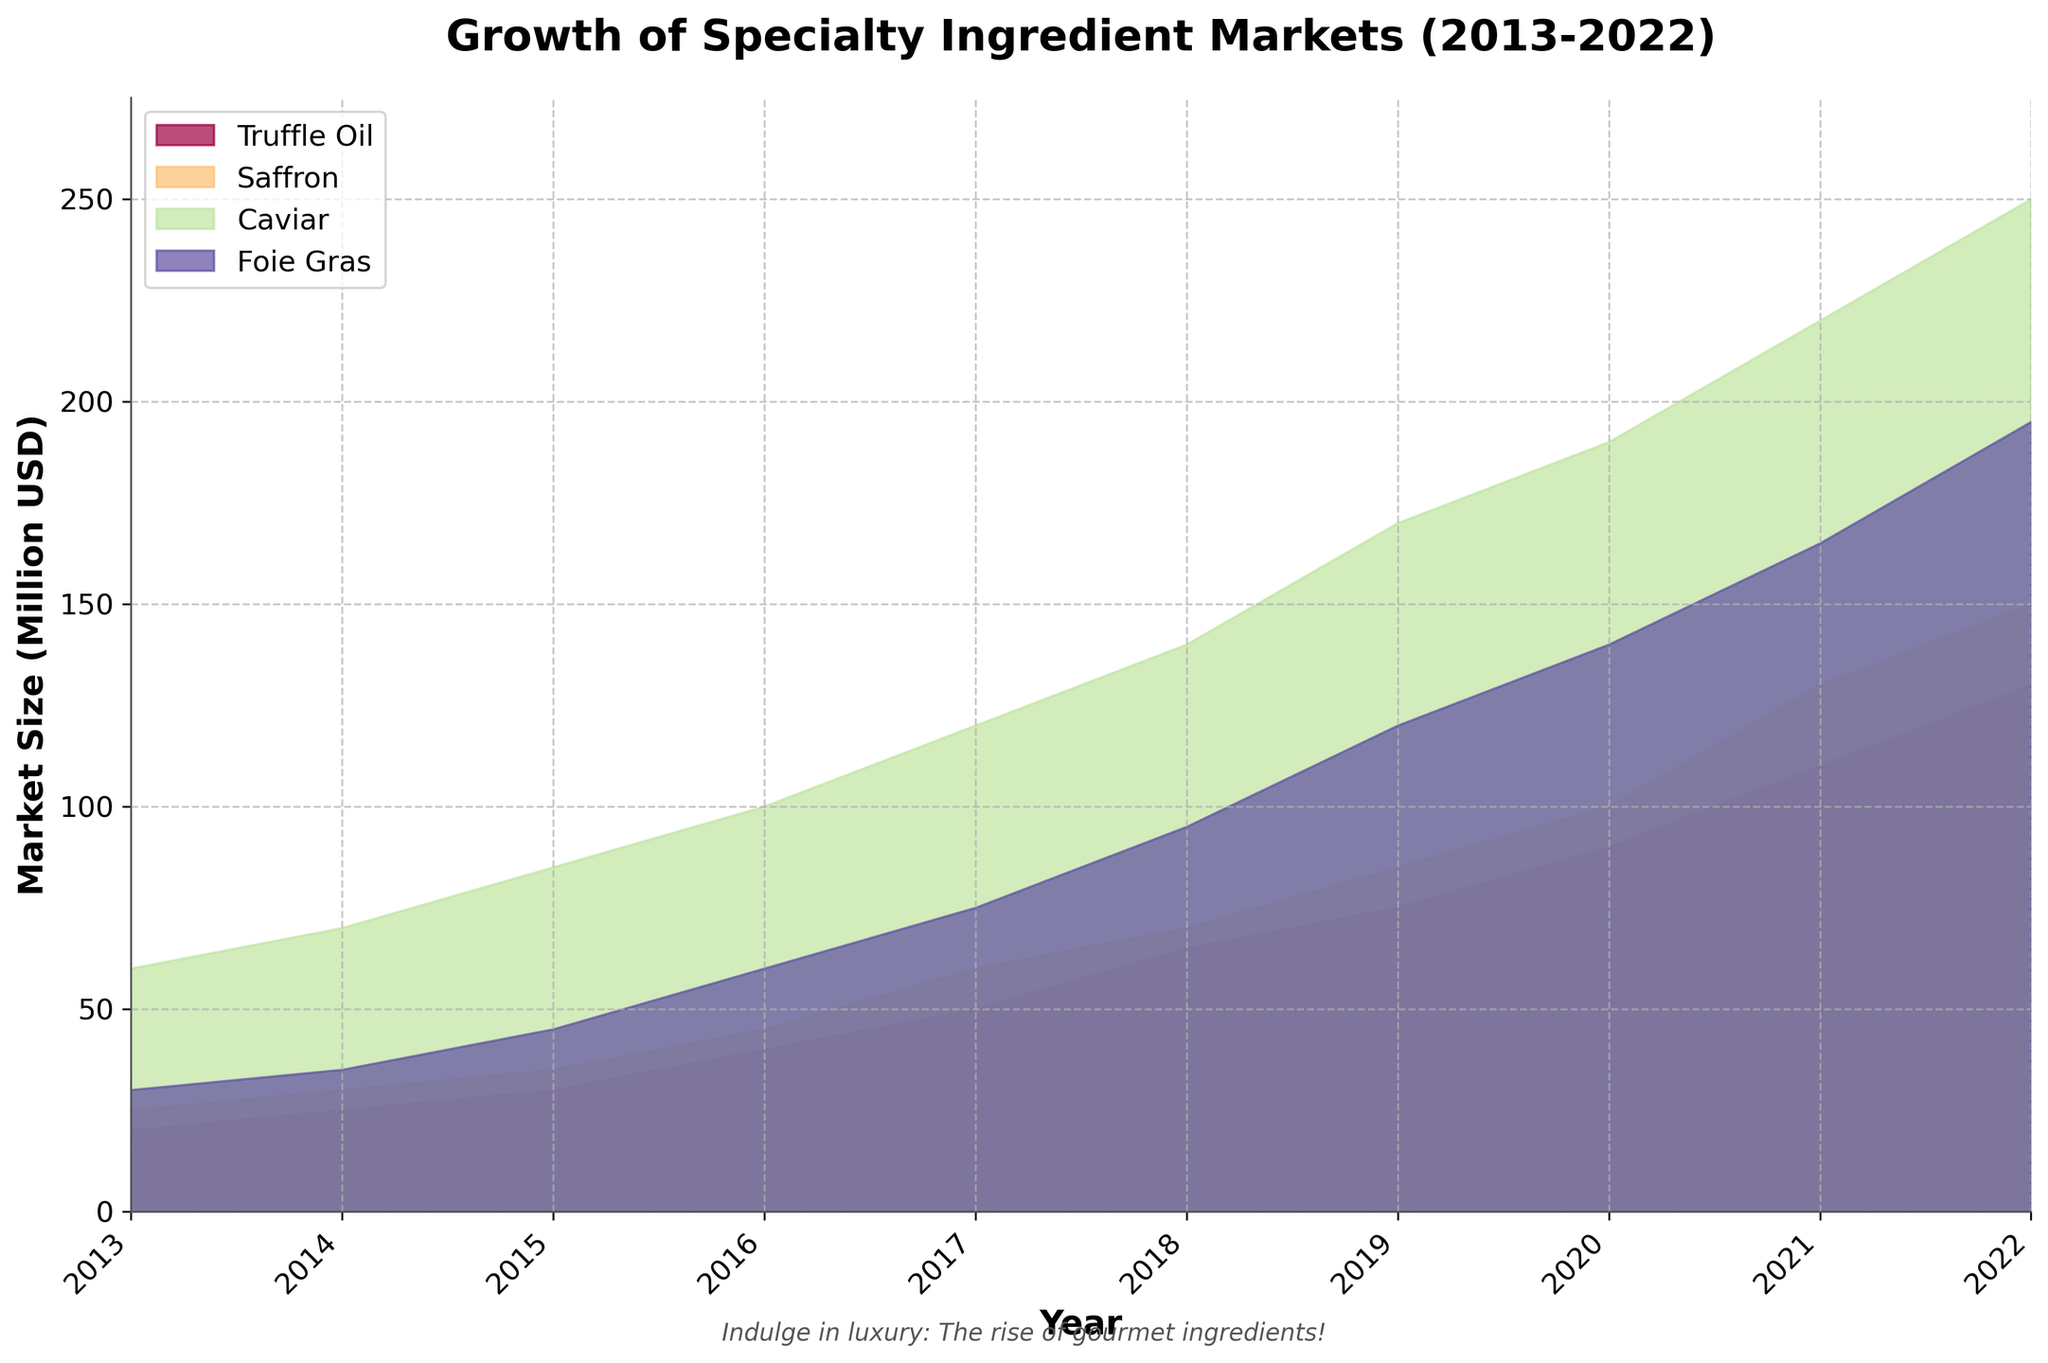What is the title of the area chart? The title of a chart is usually found at the top, and in this case, it's "Growth of Specialty Ingredient Markets (2013-2022)".
Answer: Growth of Specialty Ingredient Markets (2013-2022) Which ingredient had the largest market size in 2022? By looking at the highest point on the chart for 2022, we can see that Caviar has the largest market size.
Answer: Caviar Between which years did Foie Gras see the largest increase in market size? By comparing the size increments year over year, we can see the most significant jump is from 2017 to 2018. The market size increased from 75 million USD in 2017 to 95 million USD in 2018.
Answer: 2017-2018 Which ingredient had a consistent growth pattern over the years? By visually inspecting the area curves, Truffle Oil shows a relatively linear and consistent growth from 2013 to 2022.
Answer: Truffle Oil What was the combined market size of Truffle Oil and Saffron in 2020? Add the market size of Truffle Oil (90 million USD) and Saffron (100 million USD) in 2020.
Answer: 190 million USD How does the market size of Caviar in 2015 compare to Foie Gras in 2015? The market size of Caviar in 2015 was 85 million USD, which is almost double that of Foie Gras at 45 million USD in the same year.
Answer: Caviar is almost double Which ingredient's market size grew the most between 2013 and 2022? Calculate the growth for each ingredient: 
- Truffle Oil: 130 - 20 = 110 million USD
- Saffron: 150 - 25 = 125 million USD
- Caviar: 250 - 60 = 190 million USD
- Foie Gras: 195 - 30 = 165 million USD
Caviar has the most significant growth.
Answer: Caviar In which year did Saffron surpass Truffle Oil in market size? By comparing the areas in each year, Saffron surpassed Truffle Oil in market size in 2017.
Answer: 2017 What is the trend of the market size for Truffle Oil over the last decade? The trend is determined by inspecting the area curve of Truffle Oil from 2013 to 2022, which shows steady and continuous growth.
Answer: Steady and continuous growth 